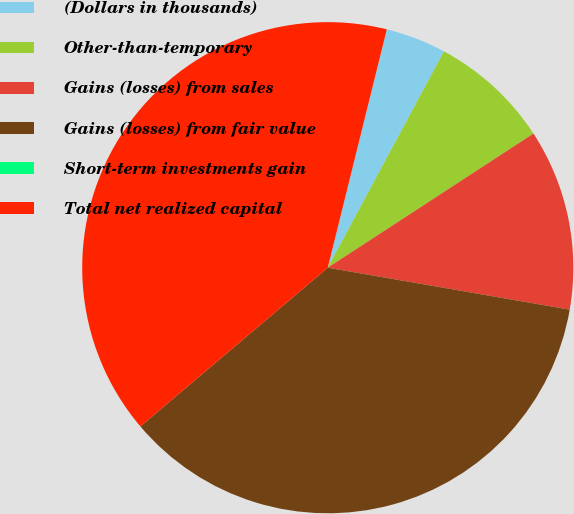<chart> <loc_0><loc_0><loc_500><loc_500><pie_chart><fcel>(Dollars in thousands)<fcel>Other-than-temporary<fcel>Gains (losses) from sales<fcel>Gains (losses) from fair value<fcel>Short-term investments gain<fcel>Total net realized capital<nl><fcel>3.98%<fcel>7.96%<fcel>11.93%<fcel>36.08%<fcel>0.0%<fcel>40.05%<nl></chart> 